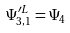Convert formula to latex. <formula><loc_0><loc_0><loc_500><loc_500>\Psi _ { 3 , 1 } ^ { \prime L } = \Psi _ { 4 }</formula> 